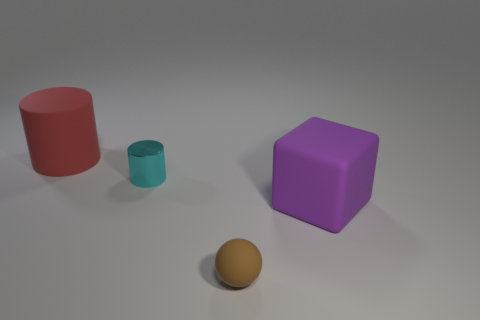Subtract 1 cubes. How many cubes are left? 0 Add 4 large brown metal cylinders. How many objects exist? 8 Subtract all cyan cylinders. How many cylinders are left? 1 Subtract all blocks. How many objects are left? 3 Subtract all brown cylinders. Subtract all cyan balls. How many cylinders are left? 2 Subtract all red blocks. How many purple balls are left? 0 Subtract all brown things. Subtract all cyan objects. How many objects are left? 2 Add 4 red matte cylinders. How many red matte cylinders are left? 5 Add 1 spheres. How many spheres exist? 2 Subtract 1 red cylinders. How many objects are left? 3 